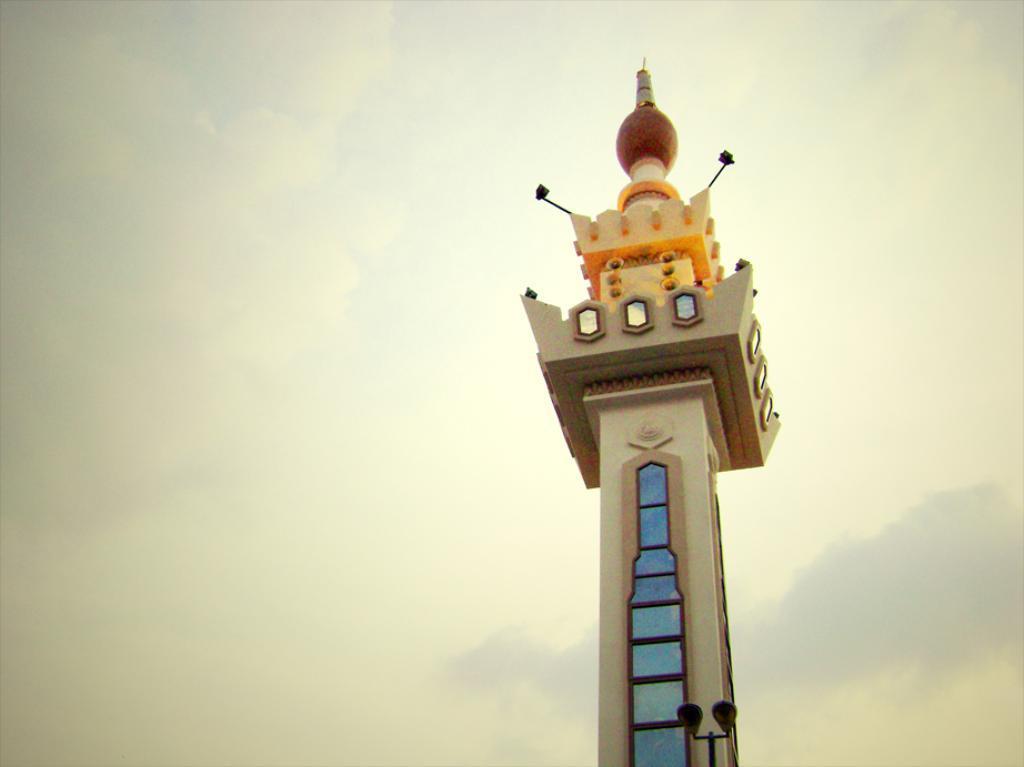Could you give a brief overview of what you see in this image? In this image there is a tower with some paintings and lamps on it, in the background of the image there are clouds in the sky. 